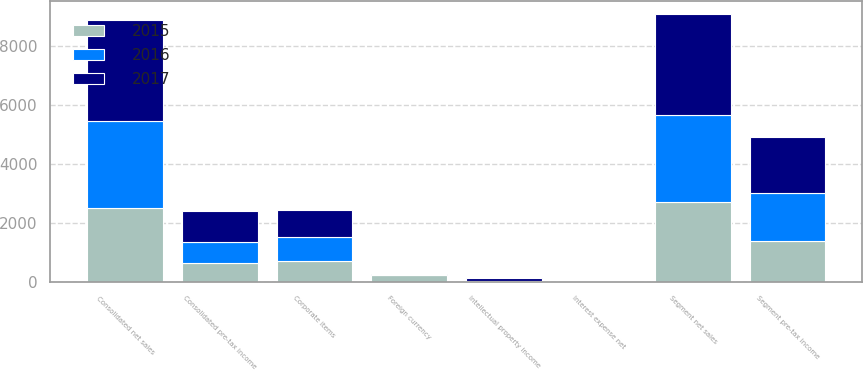Convert chart to OTSL. <chart><loc_0><loc_0><loc_500><loc_500><stacked_bar_chart><ecel><fcel>Segment net sales<fcel>Foreign currency<fcel>Consolidated net sales<fcel>Segment pre-tax income<fcel>Corporate items<fcel>Intellectual property income<fcel>Interest expense net<fcel>Consolidated pre-tax income<nl><fcel>2017<fcel>3422.1<fcel>13.2<fcel>3435.3<fcel>1920.7<fcel>895.6<fcel>73.3<fcel>2.9<fcel>1034.9<nl><fcel>2016<fcel>2944.8<fcel>18.9<fcel>2963.7<fcel>1623.7<fcel>826.1<fcel>32.6<fcel>8.4<fcel>737.9<nl><fcel>2015<fcel>2718<fcel>224.3<fcel>2493.7<fcel>1378.5<fcel>711.3<fcel>7<fcel>9.3<fcel>622.4<nl></chart> 